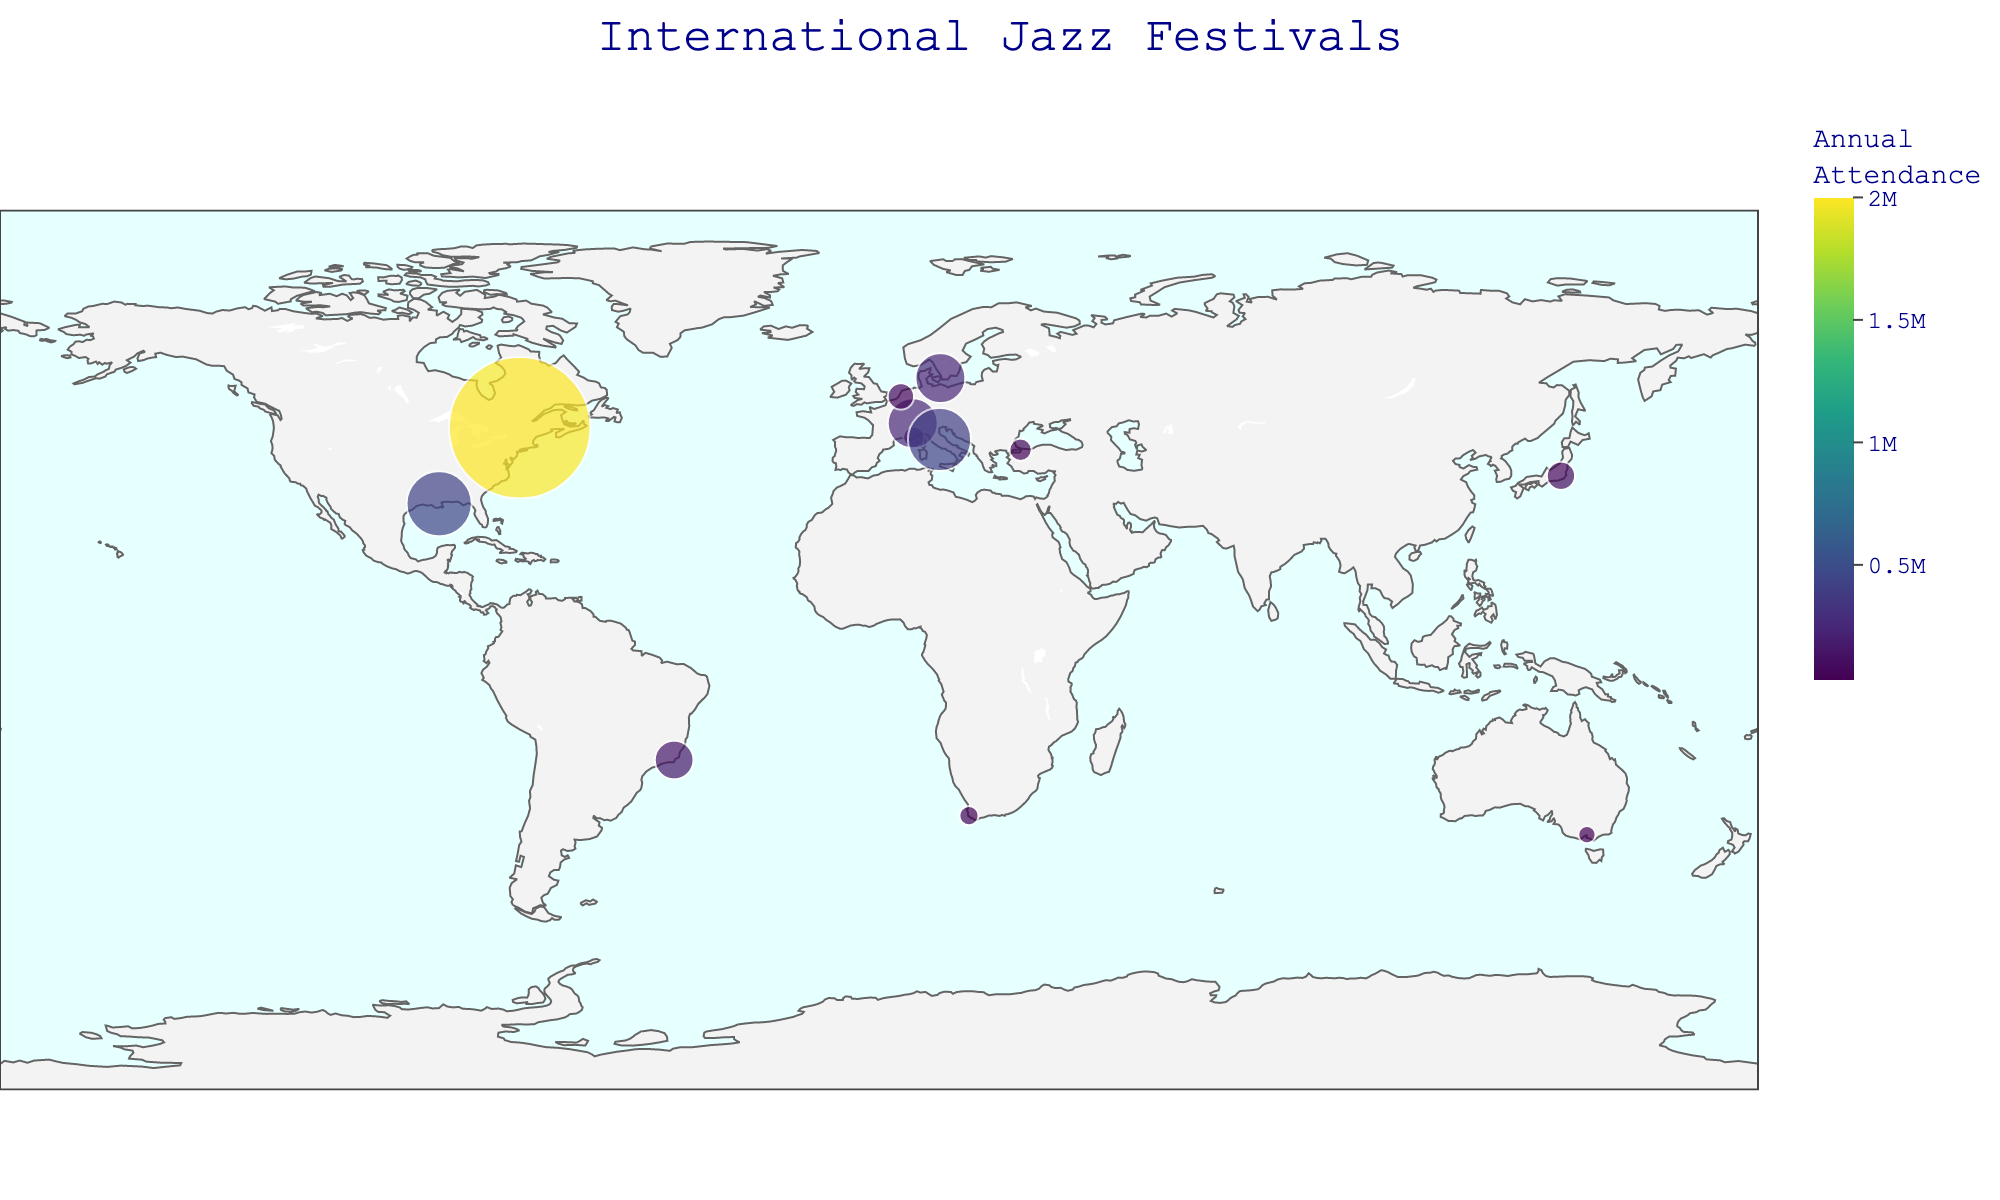What's the title of the plot? The title of the plot is usually displayed prominently, typically at the top center of the figure, summarizing the information depicted.
Answer: International Jazz Festivals How many countries have featured jazz festivals in the figure? By counting the unique countries listed in the data points plotted on the map, we determine the number of countries represented. The countries are USA, France, Switzerland, Canada, Netherlands, Japan, South Africa, Australia, Italy, Brazil, Denmark, and Turkey.
Answer: 12 Which festival has the highest annual attendance, and how much is it? Look for the festival plotted with the largest bubble size, indicated in the legend with the largest number. According to the data, the Festival International de Jazz de Montréal in Canada has the highest annual attendance.
Answer: Festival International de Jazz de Montréal, 2000000 What are the latitude and longitude ranges displayed on the map? The geographic plot uses latitude and longitude to place data points. The latitude values range roughly from -37.8 to 55.7, and the longitude values range from around -90.1 to 144.9.
Answer: Latitudes: ~-37.8 to 55.7, Longitudes: ~-90.1 to 144.9 How does the attendance of the Montreux Jazz Festival in Switzerland compare to the North Sea Jazz Festival in Rotterdam, Netherlands? Locate both festivals on the map and compare the bubble sizes or specified attendance values. Montreux Jazz Festival has an annual attendance of 250,000, while the North Sea Jazz Festival has 70,000. Therefore, the Montreux Jazz Festival has a higher attendance.
Answer: Montreux Jazz Festival has more attendees What's the average attendance of the jazz festivals in Europe? (Focus on France, Switzerland, Netherlands, Denmark, and Italy) Sum the attendance values of the festivals in these countries and divide by the number of festivals: (45000 + 250000 + 70000 + 250000 + 400000) / 5 = 1010000 / 5.
Answer: 202000 Which continent hosts the jazz festival with the lowest annual attendance? Identify the festival with the smallest bubble size or the lowest attendance number and check its location. The Cape Town International Jazz Festival in South Africa has the lowest attendance of 37,000. Therefore, the continent is Africa.
Answer: Africa How does the color scale relate to the attendance values? Pay attention to the color of the bubbles; darker colors (e.g., deep blues) typically represent higher attendance rates, while lighter colors indicate lower rates, based on a continuous color scale mapped from smallest to largest values. This pattern is evident from examining the colored bubbles in the plot.
Answer: Darker colors have higher attendance; lighter colors, lower attendance Identify a major jazz festival in each continent shown on the plot. Based on the locations of the plotted festivals, notable festivals are: New Orleans Jazz & Heritage Festival (North America), Jazz à Juan (Europe), Tokyo Jazz Festival (Asia), Cape Town International Jazz Festival (Africa), Melbourne International Jazz Festival (Australia), Rio das Ostras Jazz & Blues Festival (South America).
Answer: Various festivals per continent Which region appears to have the densest clustering of jazz festivals based on the plot? Examine the concentration of bubbles in different geographic areas; Europe has a notable number of festivals in close proximity, including festivals in France, Switzerland, Netherlands, Denmark, and Italy. This comparison reveals Europe as having the highest festival density.
Answer: Europe 